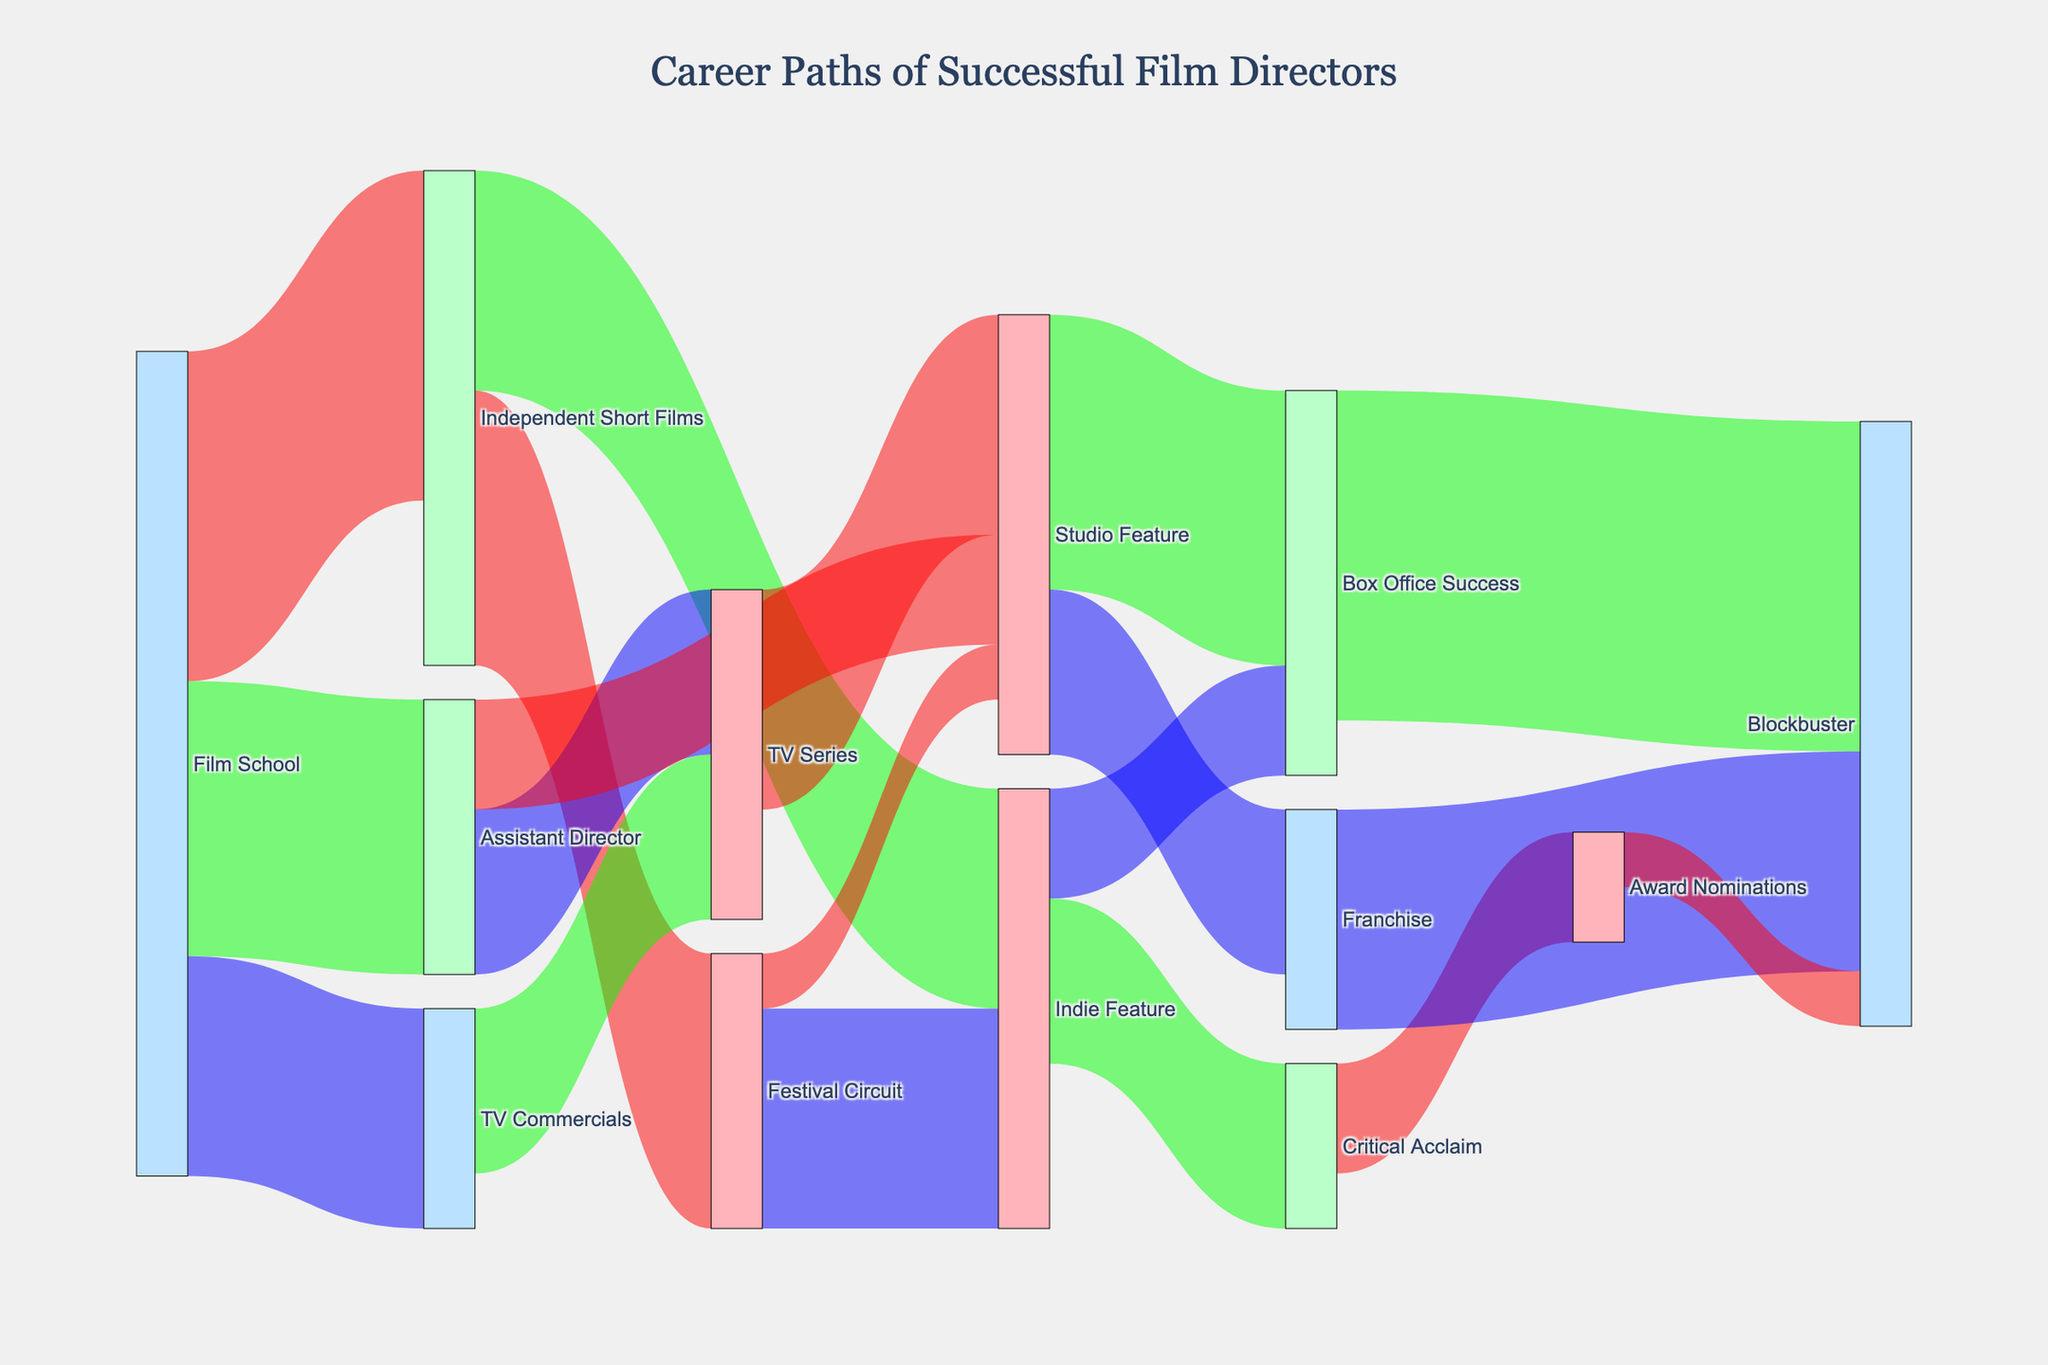How many pathways lead directly from "Film School" to other career steps? By looking at the figure and following the connections starting from "Film School," count the pathways. There are connections to "Independent Short Films," "Assistant Director," and "TV Commercials."
Answer: 3 What is the final career step that receives the highest number of directors? To determine this, find the target node with the highest value sum from all incoming streams. "Blockbuster" receives values from "Box Office Success," "Franchise," and "Award Nominations," totaling up to 55 (30 + 20 + 5).
Answer: Blockbuster Which intermediate step connects most frequently to "Studio Feature"? To find this, trace back the sources of "Studio Feature" and sum up their values: "Assistant Director" (10), "TV Series" (20), and "Festival Circuit" (5).
Answer: TV Series If a director went from "Critical Acclaim" to a final career step, where would they most likely end up? Trace the connections from "Critical Acclaim" and add up their values. The options are "Award Nominations" (10), which directly leads to "Blockbuster" (5). Therefore "Blockbuster" is the final step most likely taken, but it's via "Award Nominations."
Answer: Blockbuster What proportion of directors who start at "Independent Short Films" end up at "Indie Feature"? First, identify the connections from "Independent Short Films" and their values: "Festival Circuit" (25) and "Indie Feature" (20). Then calculate the proportion: 20/(25+20) = 20/45 ≈ 0.44.
Answer: Approximately 0.44 (or 44%) How many steps are there between "Film School" and "Blockbuster"? Follow the longest possible pathway: "Film School" → "Independent Short Films" → "Festival Circuit" → "Studio Feature" → "Box Office Success" → "Blockbuster." This counts as 5 steps.
Answer: 5 Which paths contribute to the "Franchise" destination and with how many directors each? Identify the direct connections to "Franchise" which is only from "Studio Feature" with a value of 15.
Answer: Studio Feature (15) Compare the number of directors who move from "Assistant Director" to "TV Series" versus those who go to "Studio Feature." Which path is more common? From "Assistant Director," follow the connections to "TV Series" (15) and "Studio Feature" (10). Compare the values: 15 > 10.
Answer: TV Series Is there a direct connection between "TV Commercials" and a final career step? If yes, what is it? Follow the paths from "TV Commercials" and check if any reach a final career step without intermediates. There is no path directly connecting "TV Commercials" to a final career step without intermediates.
Answer: No Where do directors starting from "Festival Circuit" most frequently advance next? Identify the connections from "Festival Circuit" and compare their values: "Indie Feature" (20) and "Studio Feature" (5). The highest value is 20.
Answer: Indie Feature 